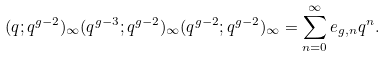Convert formula to latex. <formula><loc_0><loc_0><loc_500><loc_500>( q ; q ^ { g - 2 } ) _ { \infty } ( q ^ { g - 3 } ; q ^ { g - 2 } ) _ { \infty } ( q ^ { g - 2 } ; q ^ { g - 2 } ) _ { \infty } & = \sum _ { n = 0 } ^ { \infty } e _ { g , n } q ^ { n } .</formula> 